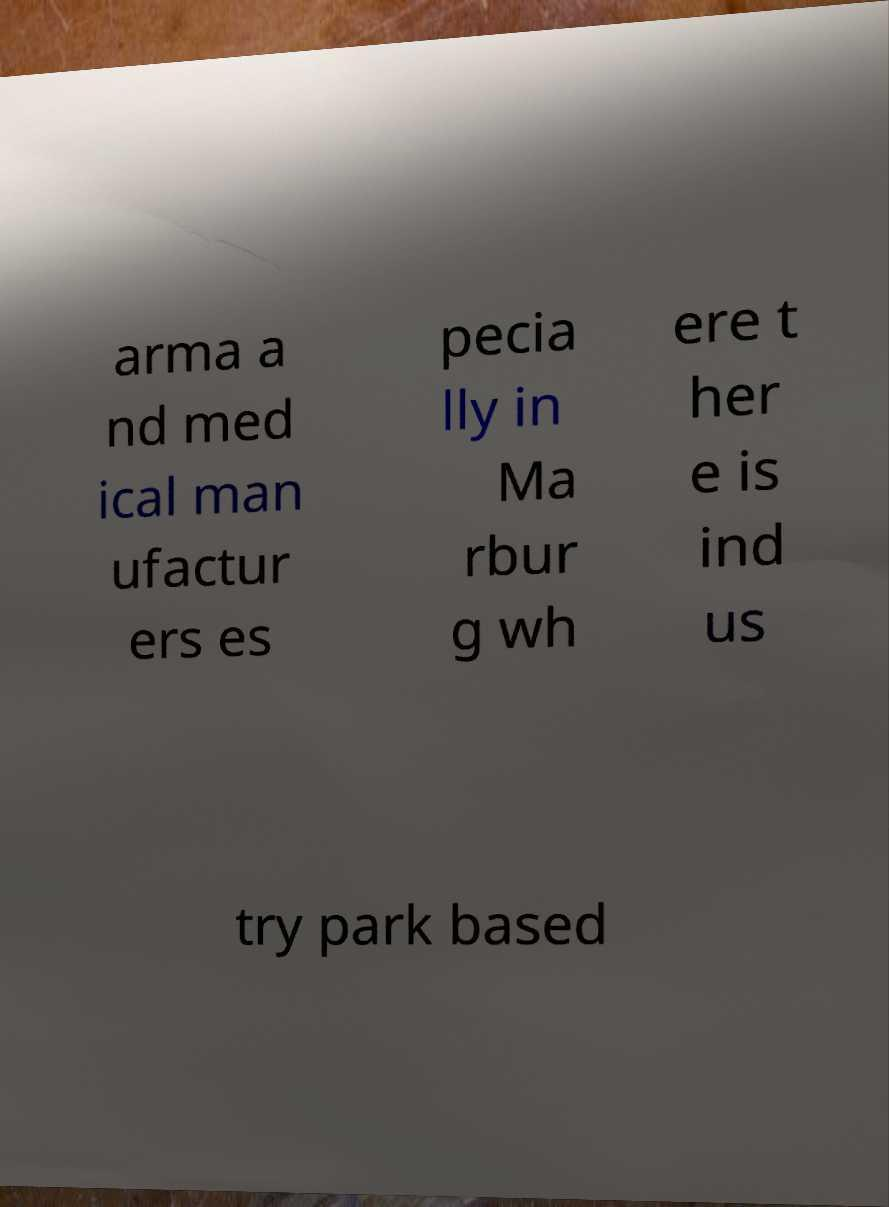Please read and relay the text visible in this image. What does it say? arma a nd med ical man ufactur ers es pecia lly in Ma rbur g wh ere t her e is ind us try park based 